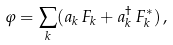<formula> <loc_0><loc_0><loc_500><loc_500>\varphi = \sum _ { k } ( a _ { k } \, F _ { k } + a ^ { \dagger } _ { k } \, F ^ { * } _ { k } ) \, ,</formula> 